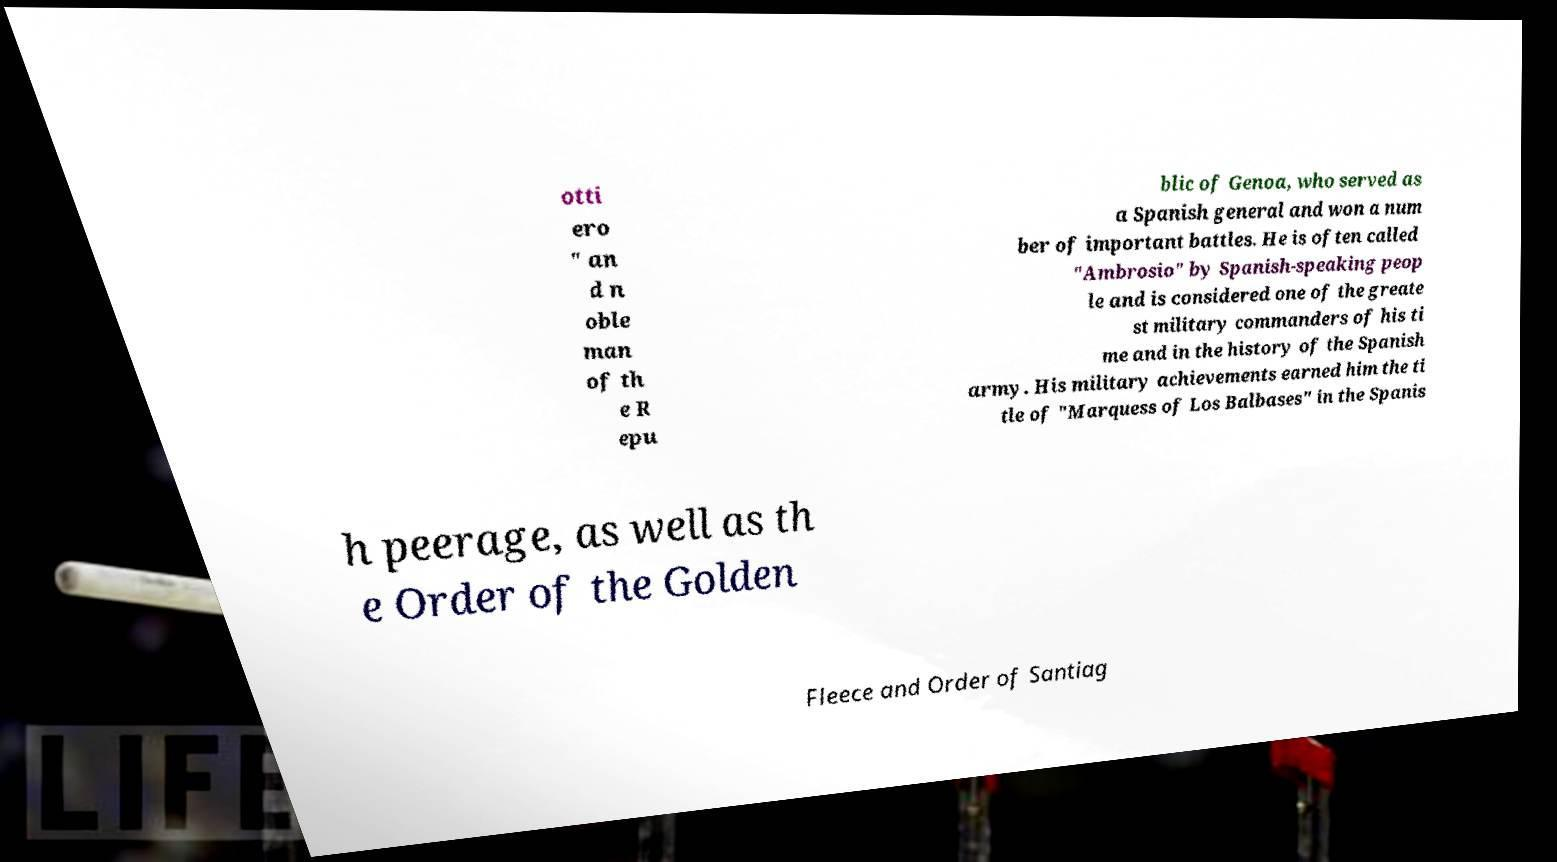Can you read and provide the text displayed in the image?This photo seems to have some interesting text. Can you extract and type it out for me? otti ero " an d n oble man of th e R epu blic of Genoa, who served as a Spanish general and won a num ber of important battles. He is often called "Ambrosio" by Spanish-speaking peop le and is considered one of the greate st military commanders of his ti me and in the history of the Spanish army. His military achievements earned him the ti tle of "Marquess of Los Balbases" in the Spanis h peerage, as well as th e Order of the Golden Fleece and Order of Santiag 